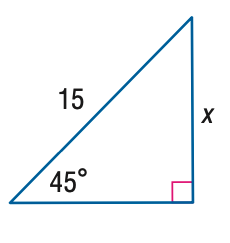Answer the mathemtical geometry problem and directly provide the correct option letter.
Question: Find x.
Choices: A: \frac { 15 } { 2 } B: \frac { 15 \sqrt { 2 } } { 2 } C: \frac { 15 \sqrt { 3 } } { 2 } D: 15 \sqrt { 2 } B 